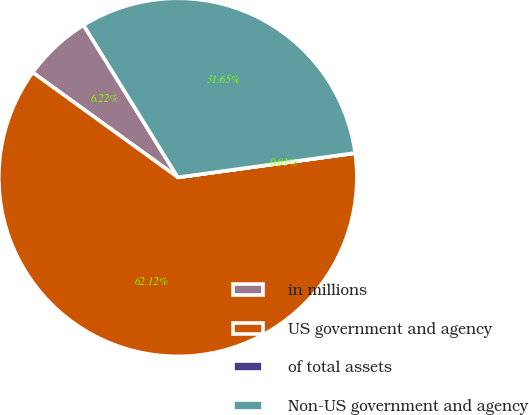Convert chart to OTSL. <chart><loc_0><loc_0><loc_500><loc_500><pie_chart><fcel>in millions<fcel>US government and agency<fcel>of total assets<fcel>Non-US government and agency<nl><fcel>6.22%<fcel>62.12%<fcel>0.01%<fcel>31.65%<nl></chart> 